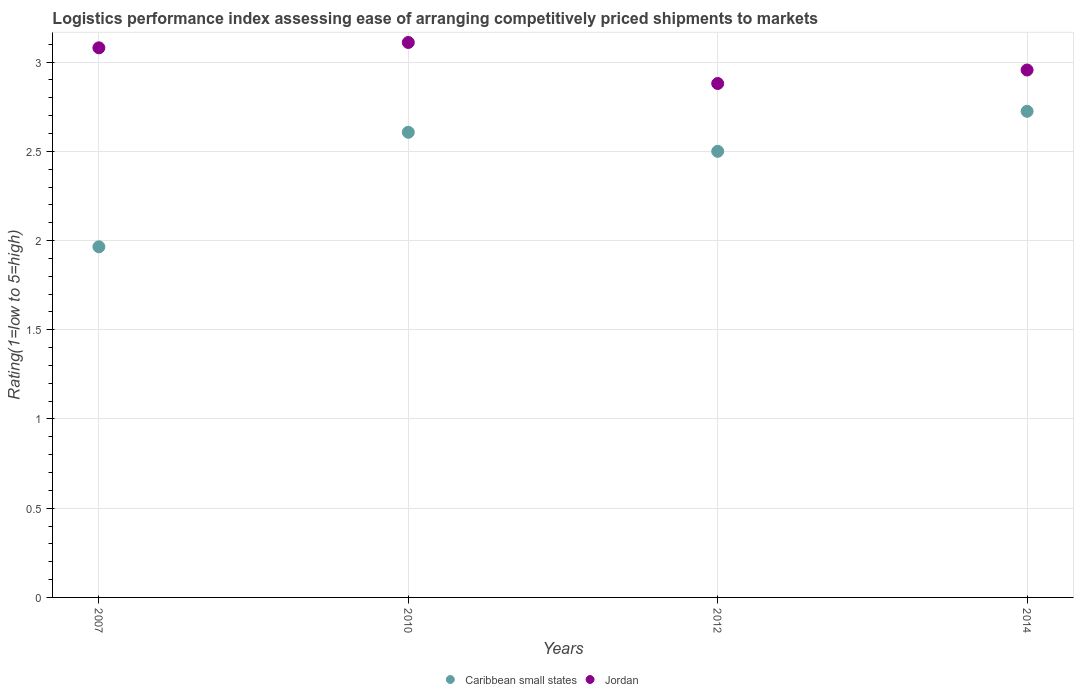Across all years, what is the maximum Logistic performance index in Caribbean small states?
Make the answer very short. 2.72. Across all years, what is the minimum Logistic performance index in Caribbean small states?
Make the answer very short. 1.97. In which year was the Logistic performance index in Caribbean small states maximum?
Provide a short and direct response. 2014. In which year was the Logistic performance index in Jordan minimum?
Make the answer very short. 2012. What is the total Logistic performance index in Jordan in the graph?
Your answer should be very brief. 12.03. What is the difference between the Logistic performance index in Jordan in 2010 and that in 2014?
Your answer should be compact. 0.15. What is the difference between the Logistic performance index in Jordan in 2007 and the Logistic performance index in Caribbean small states in 2012?
Your answer should be compact. 0.58. What is the average Logistic performance index in Caribbean small states per year?
Give a very brief answer. 2.45. In the year 2010, what is the difference between the Logistic performance index in Caribbean small states and Logistic performance index in Jordan?
Your response must be concise. -0.5. What is the ratio of the Logistic performance index in Jordan in 2007 to that in 2012?
Provide a succinct answer. 1.07. Is the difference between the Logistic performance index in Caribbean small states in 2007 and 2010 greater than the difference between the Logistic performance index in Jordan in 2007 and 2010?
Your response must be concise. No. What is the difference between the highest and the second highest Logistic performance index in Caribbean small states?
Your answer should be compact. 0.12. What is the difference between the highest and the lowest Logistic performance index in Jordan?
Make the answer very short. 0.23. In how many years, is the Logistic performance index in Caribbean small states greater than the average Logistic performance index in Caribbean small states taken over all years?
Ensure brevity in your answer.  3. Does the Logistic performance index in Jordan monotonically increase over the years?
Make the answer very short. No. How many dotlines are there?
Ensure brevity in your answer.  2. How many years are there in the graph?
Your answer should be very brief. 4. What is the title of the graph?
Your answer should be compact. Logistics performance index assessing ease of arranging competitively priced shipments to markets. What is the label or title of the X-axis?
Give a very brief answer. Years. What is the label or title of the Y-axis?
Your response must be concise. Rating(1=low to 5=high). What is the Rating(1=low to 5=high) of Caribbean small states in 2007?
Make the answer very short. 1.97. What is the Rating(1=low to 5=high) of Jordan in 2007?
Provide a short and direct response. 3.08. What is the Rating(1=low to 5=high) in Caribbean small states in 2010?
Keep it short and to the point. 2.61. What is the Rating(1=low to 5=high) of Jordan in 2010?
Ensure brevity in your answer.  3.11. What is the Rating(1=low to 5=high) in Caribbean small states in 2012?
Give a very brief answer. 2.5. What is the Rating(1=low to 5=high) of Jordan in 2012?
Offer a very short reply. 2.88. What is the Rating(1=low to 5=high) in Caribbean small states in 2014?
Ensure brevity in your answer.  2.72. What is the Rating(1=low to 5=high) of Jordan in 2014?
Your answer should be very brief. 2.96. Across all years, what is the maximum Rating(1=low to 5=high) of Caribbean small states?
Provide a succinct answer. 2.72. Across all years, what is the maximum Rating(1=low to 5=high) of Jordan?
Give a very brief answer. 3.11. Across all years, what is the minimum Rating(1=low to 5=high) in Caribbean small states?
Give a very brief answer. 1.97. Across all years, what is the minimum Rating(1=low to 5=high) in Jordan?
Offer a very short reply. 2.88. What is the total Rating(1=low to 5=high) in Caribbean small states in the graph?
Your response must be concise. 9.8. What is the total Rating(1=low to 5=high) in Jordan in the graph?
Your answer should be very brief. 12.03. What is the difference between the Rating(1=low to 5=high) of Caribbean small states in 2007 and that in 2010?
Keep it short and to the point. -0.64. What is the difference between the Rating(1=low to 5=high) in Jordan in 2007 and that in 2010?
Provide a short and direct response. -0.03. What is the difference between the Rating(1=low to 5=high) of Caribbean small states in 2007 and that in 2012?
Give a very brief answer. -0.54. What is the difference between the Rating(1=low to 5=high) of Jordan in 2007 and that in 2012?
Make the answer very short. 0.2. What is the difference between the Rating(1=low to 5=high) of Caribbean small states in 2007 and that in 2014?
Keep it short and to the point. -0.76. What is the difference between the Rating(1=low to 5=high) of Jordan in 2007 and that in 2014?
Give a very brief answer. 0.12. What is the difference between the Rating(1=low to 5=high) of Caribbean small states in 2010 and that in 2012?
Give a very brief answer. 0.11. What is the difference between the Rating(1=low to 5=high) of Jordan in 2010 and that in 2012?
Make the answer very short. 0.23. What is the difference between the Rating(1=low to 5=high) in Caribbean small states in 2010 and that in 2014?
Provide a short and direct response. -0.12. What is the difference between the Rating(1=low to 5=high) in Jordan in 2010 and that in 2014?
Keep it short and to the point. 0.15. What is the difference between the Rating(1=low to 5=high) in Caribbean small states in 2012 and that in 2014?
Your response must be concise. -0.22. What is the difference between the Rating(1=low to 5=high) of Jordan in 2012 and that in 2014?
Your answer should be very brief. -0.08. What is the difference between the Rating(1=low to 5=high) of Caribbean small states in 2007 and the Rating(1=low to 5=high) of Jordan in 2010?
Provide a short and direct response. -1.15. What is the difference between the Rating(1=low to 5=high) of Caribbean small states in 2007 and the Rating(1=low to 5=high) of Jordan in 2012?
Provide a succinct answer. -0.92. What is the difference between the Rating(1=low to 5=high) of Caribbean small states in 2007 and the Rating(1=low to 5=high) of Jordan in 2014?
Your answer should be compact. -0.99. What is the difference between the Rating(1=low to 5=high) in Caribbean small states in 2010 and the Rating(1=low to 5=high) in Jordan in 2012?
Provide a succinct answer. -0.27. What is the difference between the Rating(1=low to 5=high) of Caribbean small states in 2010 and the Rating(1=low to 5=high) of Jordan in 2014?
Your answer should be compact. -0.35. What is the difference between the Rating(1=low to 5=high) of Caribbean small states in 2012 and the Rating(1=low to 5=high) of Jordan in 2014?
Your answer should be very brief. -0.46. What is the average Rating(1=low to 5=high) in Caribbean small states per year?
Ensure brevity in your answer.  2.45. What is the average Rating(1=low to 5=high) of Jordan per year?
Offer a terse response. 3.01. In the year 2007, what is the difference between the Rating(1=low to 5=high) of Caribbean small states and Rating(1=low to 5=high) of Jordan?
Give a very brief answer. -1.11. In the year 2010, what is the difference between the Rating(1=low to 5=high) of Caribbean small states and Rating(1=low to 5=high) of Jordan?
Make the answer very short. -0.5. In the year 2012, what is the difference between the Rating(1=low to 5=high) of Caribbean small states and Rating(1=low to 5=high) of Jordan?
Provide a short and direct response. -0.38. In the year 2014, what is the difference between the Rating(1=low to 5=high) of Caribbean small states and Rating(1=low to 5=high) of Jordan?
Offer a terse response. -0.23. What is the ratio of the Rating(1=low to 5=high) of Caribbean small states in 2007 to that in 2010?
Make the answer very short. 0.75. What is the ratio of the Rating(1=low to 5=high) in Caribbean small states in 2007 to that in 2012?
Your response must be concise. 0.79. What is the ratio of the Rating(1=low to 5=high) in Jordan in 2007 to that in 2012?
Ensure brevity in your answer.  1.07. What is the ratio of the Rating(1=low to 5=high) of Caribbean small states in 2007 to that in 2014?
Give a very brief answer. 0.72. What is the ratio of the Rating(1=low to 5=high) in Jordan in 2007 to that in 2014?
Provide a short and direct response. 1.04. What is the ratio of the Rating(1=low to 5=high) in Caribbean small states in 2010 to that in 2012?
Keep it short and to the point. 1.04. What is the ratio of the Rating(1=low to 5=high) in Jordan in 2010 to that in 2012?
Provide a short and direct response. 1.08. What is the ratio of the Rating(1=low to 5=high) in Caribbean small states in 2010 to that in 2014?
Offer a terse response. 0.96. What is the ratio of the Rating(1=low to 5=high) in Jordan in 2010 to that in 2014?
Ensure brevity in your answer.  1.05. What is the ratio of the Rating(1=low to 5=high) of Caribbean small states in 2012 to that in 2014?
Provide a succinct answer. 0.92. What is the ratio of the Rating(1=low to 5=high) in Jordan in 2012 to that in 2014?
Provide a short and direct response. 0.97. What is the difference between the highest and the second highest Rating(1=low to 5=high) in Caribbean small states?
Offer a very short reply. 0.12. What is the difference between the highest and the lowest Rating(1=low to 5=high) of Caribbean small states?
Offer a terse response. 0.76. What is the difference between the highest and the lowest Rating(1=low to 5=high) of Jordan?
Offer a very short reply. 0.23. 